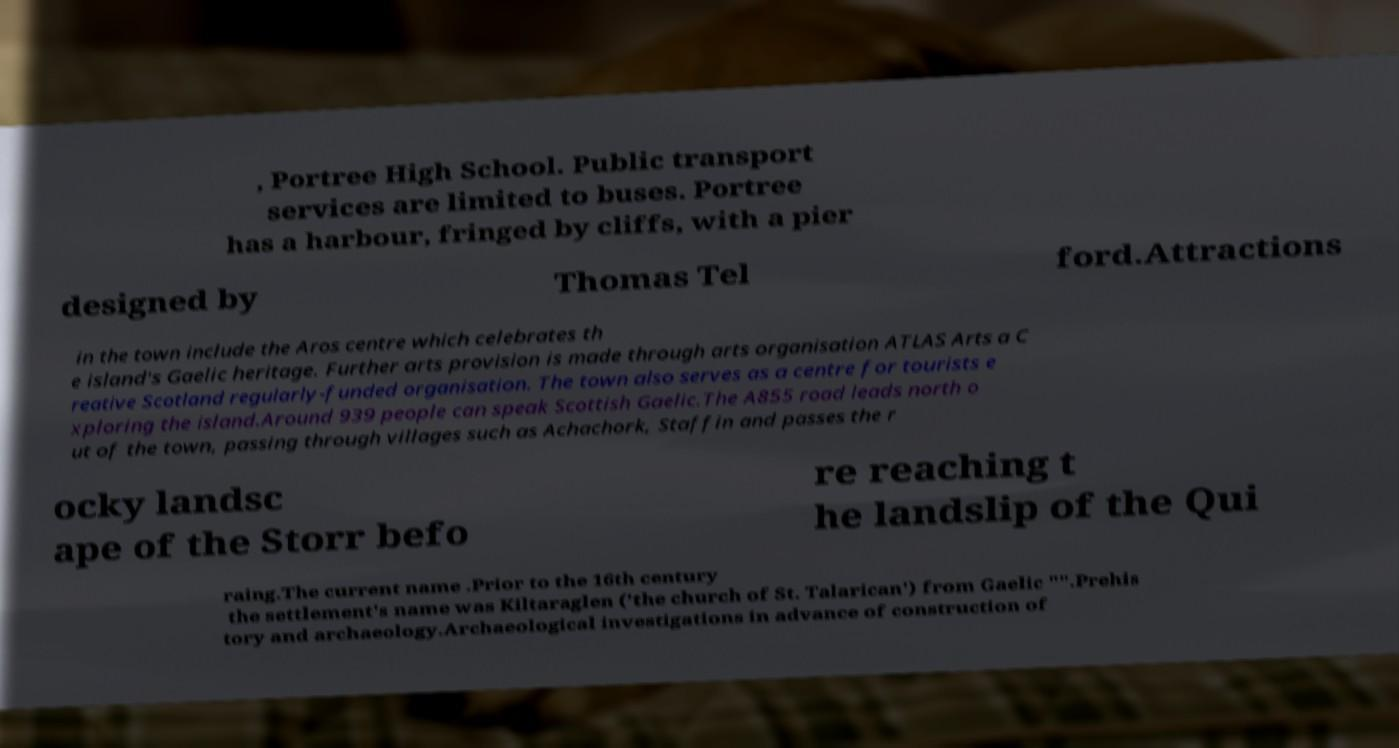Could you extract and type out the text from this image? , Portree High School. Public transport services are limited to buses. Portree has a harbour, fringed by cliffs, with a pier designed by Thomas Tel ford.Attractions in the town include the Aros centre which celebrates th e island's Gaelic heritage. Further arts provision is made through arts organisation ATLAS Arts a C reative Scotland regularly-funded organisation. The town also serves as a centre for tourists e xploring the island.Around 939 people can speak Scottish Gaelic.The A855 road leads north o ut of the town, passing through villages such as Achachork, Staffin and passes the r ocky landsc ape of the Storr befo re reaching t he landslip of the Qui raing.The current name .Prior to the 16th century the settlement's name was Kiltaraglen ('the church of St. Talarican') from Gaelic "".Prehis tory and archaeology.Archaeological investigations in advance of construction of 